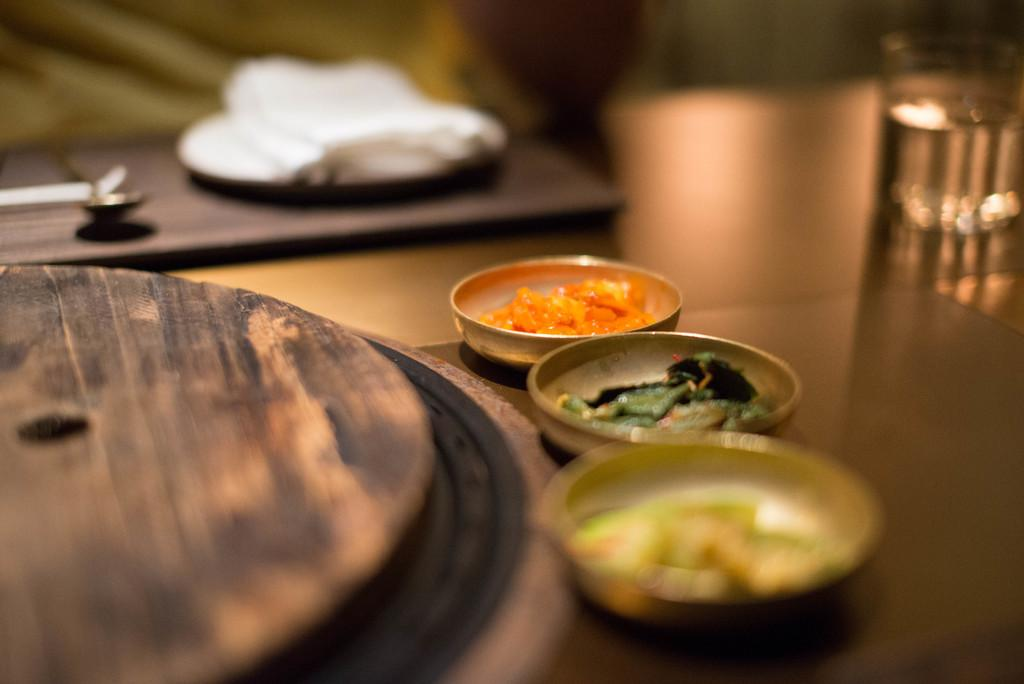What is located in the foreground of the image? There is a table in the foreground of the image. What can be found on the table? There are bowls with food items, a glass, tissues, and a spoon on the table. How many bowls are there on the table? The number of bowls is not specified, but there are multiple bowls with food items on the table. What type of vegetable is being used as a slipper in the image? There is no vegetable being used as a slipper in the image; it only features a table with bowls, a glass, tissues, and a spoon. 